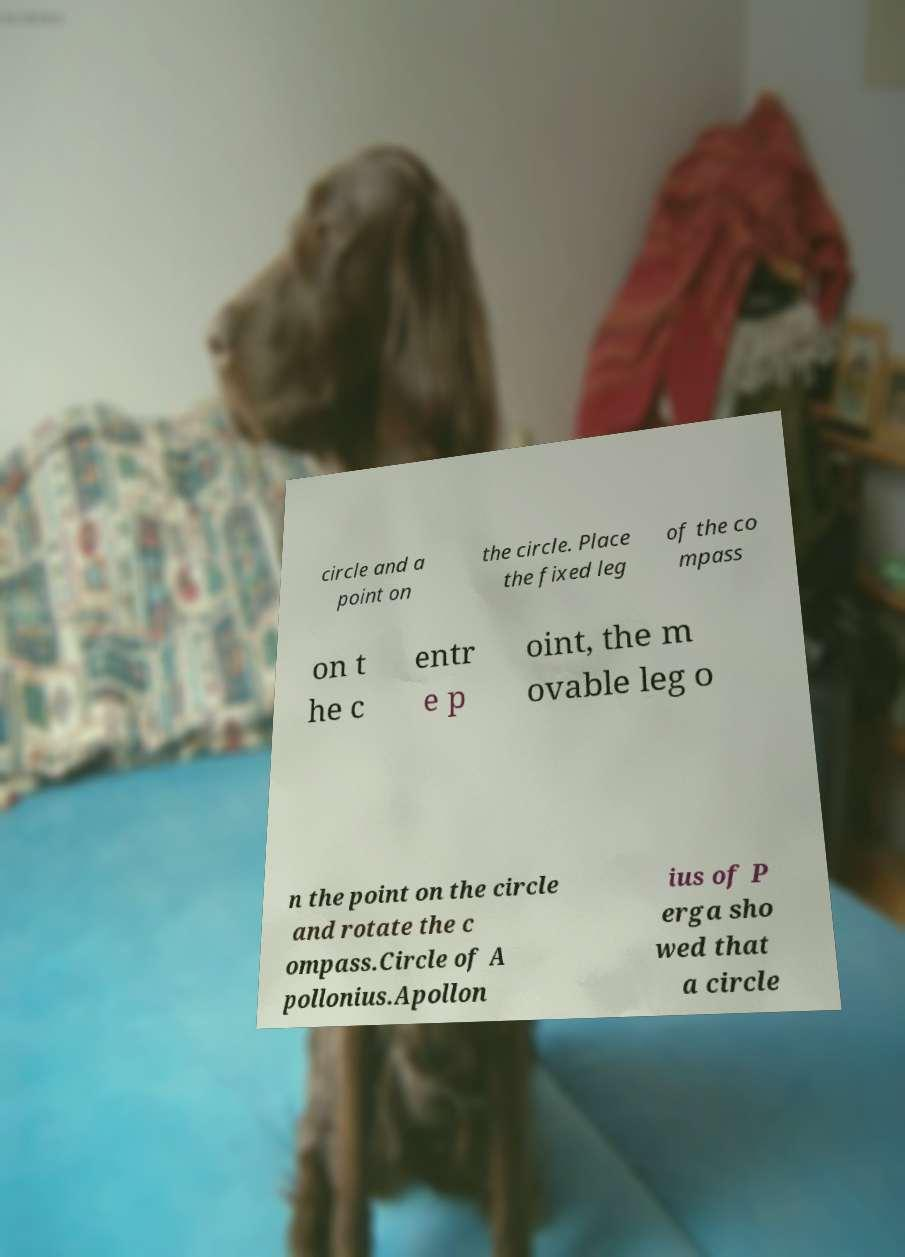Can you read and provide the text displayed in the image?This photo seems to have some interesting text. Can you extract and type it out for me? circle and a point on the circle. Place the fixed leg of the co mpass on t he c entr e p oint, the m ovable leg o n the point on the circle and rotate the c ompass.Circle of A pollonius.Apollon ius of P erga sho wed that a circle 